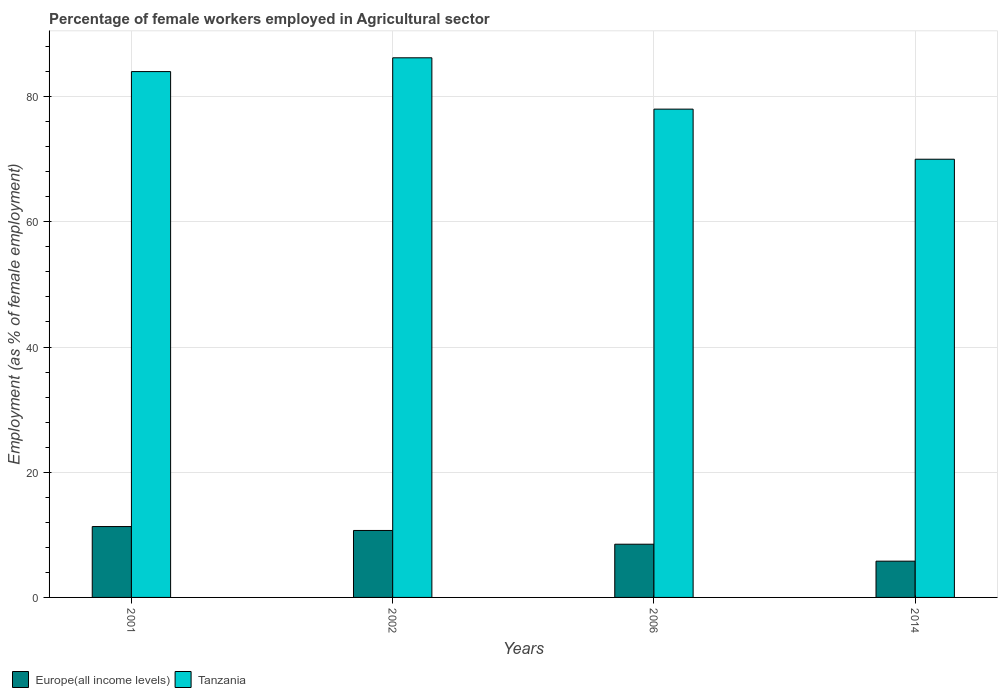Are the number of bars on each tick of the X-axis equal?
Keep it short and to the point. Yes. How many bars are there on the 4th tick from the left?
Give a very brief answer. 2. How many bars are there on the 4th tick from the right?
Offer a very short reply. 2. What is the label of the 2nd group of bars from the left?
Provide a succinct answer. 2002. In how many cases, is the number of bars for a given year not equal to the number of legend labels?
Provide a succinct answer. 0. What is the percentage of females employed in Agricultural sector in Europe(all income levels) in 2006?
Your answer should be very brief. 8.5. Across all years, what is the maximum percentage of females employed in Agricultural sector in Tanzania?
Give a very brief answer. 86.2. Across all years, what is the minimum percentage of females employed in Agricultural sector in Europe(all income levels)?
Provide a succinct answer. 5.79. In which year was the percentage of females employed in Agricultural sector in Tanzania minimum?
Give a very brief answer. 2014. What is the total percentage of females employed in Agricultural sector in Tanzania in the graph?
Provide a succinct answer. 318.2. What is the difference between the percentage of females employed in Agricultural sector in Europe(all income levels) in 2002 and that in 2006?
Keep it short and to the point. 2.2. What is the difference between the percentage of females employed in Agricultural sector in Europe(all income levels) in 2001 and the percentage of females employed in Agricultural sector in Tanzania in 2006?
Your answer should be compact. -66.68. What is the average percentage of females employed in Agricultural sector in Tanzania per year?
Provide a succinct answer. 79.55. In the year 2002, what is the difference between the percentage of females employed in Agricultural sector in Europe(all income levels) and percentage of females employed in Agricultural sector in Tanzania?
Ensure brevity in your answer.  -75.5. In how many years, is the percentage of females employed in Agricultural sector in Europe(all income levels) greater than 4 %?
Keep it short and to the point. 4. What is the ratio of the percentage of females employed in Agricultural sector in Europe(all income levels) in 2002 to that in 2006?
Make the answer very short. 1.26. What is the difference between the highest and the second highest percentage of females employed in Agricultural sector in Tanzania?
Your answer should be compact. 2.2. What is the difference between the highest and the lowest percentage of females employed in Agricultural sector in Tanzania?
Your response must be concise. 16.2. In how many years, is the percentage of females employed in Agricultural sector in Tanzania greater than the average percentage of females employed in Agricultural sector in Tanzania taken over all years?
Your answer should be very brief. 2. Is the sum of the percentage of females employed in Agricultural sector in Tanzania in 2001 and 2002 greater than the maximum percentage of females employed in Agricultural sector in Europe(all income levels) across all years?
Offer a very short reply. Yes. What does the 1st bar from the left in 2006 represents?
Give a very brief answer. Europe(all income levels). What does the 1st bar from the right in 2002 represents?
Your answer should be compact. Tanzania. Are all the bars in the graph horizontal?
Your answer should be compact. No. Does the graph contain any zero values?
Provide a short and direct response. No. Where does the legend appear in the graph?
Give a very brief answer. Bottom left. How many legend labels are there?
Keep it short and to the point. 2. How are the legend labels stacked?
Give a very brief answer. Horizontal. What is the title of the graph?
Your answer should be compact. Percentage of female workers employed in Agricultural sector. What is the label or title of the Y-axis?
Offer a very short reply. Employment (as % of female employment). What is the Employment (as % of female employment) of Europe(all income levels) in 2001?
Offer a terse response. 11.32. What is the Employment (as % of female employment) of Tanzania in 2001?
Offer a terse response. 84. What is the Employment (as % of female employment) in Europe(all income levels) in 2002?
Give a very brief answer. 10.7. What is the Employment (as % of female employment) in Tanzania in 2002?
Ensure brevity in your answer.  86.2. What is the Employment (as % of female employment) of Europe(all income levels) in 2006?
Provide a short and direct response. 8.5. What is the Employment (as % of female employment) of Europe(all income levels) in 2014?
Your response must be concise. 5.79. What is the Employment (as % of female employment) in Tanzania in 2014?
Provide a short and direct response. 70. Across all years, what is the maximum Employment (as % of female employment) in Europe(all income levels)?
Your answer should be compact. 11.32. Across all years, what is the maximum Employment (as % of female employment) in Tanzania?
Provide a short and direct response. 86.2. Across all years, what is the minimum Employment (as % of female employment) of Europe(all income levels)?
Make the answer very short. 5.79. What is the total Employment (as % of female employment) in Europe(all income levels) in the graph?
Keep it short and to the point. 36.31. What is the total Employment (as % of female employment) in Tanzania in the graph?
Give a very brief answer. 318.2. What is the difference between the Employment (as % of female employment) in Europe(all income levels) in 2001 and that in 2002?
Offer a terse response. 0.62. What is the difference between the Employment (as % of female employment) in Europe(all income levels) in 2001 and that in 2006?
Your answer should be very brief. 2.82. What is the difference between the Employment (as % of female employment) in Tanzania in 2001 and that in 2006?
Keep it short and to the point. 6. What is the difference between the Employment (as % of female employment) in Europe(all income levels) in 2001 and that in 2014?
Your answer should be very brief. 5.53. What is the difference between the Employment (as % of female employment) of Europe(all income levels) in 2002 and that in 2006?
Offer a very short reply. 2.2. What is the difference between the Employment (as % of female employment) of Europe(all income levels) in 2002 and that in 2014?
Ensure brevity in your answer.  4.9. What is the difference between the Employment (as % of female employment) of Tanzania in 2002 and that in 2014?
Keep it short and to the point. 16.2. What is the difference between the Employment (as % of female employment) of Europe(all income levels) in 2006 and that in 2014?
Offer a very short reply. 2.71. What is the difference between the Employment (as % of female employment) of Tanzania in 2006 and that in 2014?
Offer a very short reply. 8. What is the difference between the Employment (as % of female employment) of Europe(all income levels) in 2001 and the Employment (as % of female employment) of Tanzania in 2002?
Provide a short and direct response. -74.88. What is the difference between the Employment (as % of female employment) in Europe(all income levels) in 2001 and the Employment (as % of female employment) in Tanzania in 2006?
Offer a very short reply. -66.68. What is the difference between the Employment (as % of female employment) in Europe(all income levels) in 2001 and the Employment (as % of female employment) in Tanzania in 2014?
Your answer should be very brief. -58.68. What is the difference between the Employment (as % of female employment) of Europe(all income levels) in 2002 and the Employment (as % of female employment) of Tanzania in 2006?
Give a very brief answer. -67.3. What is the difference between the Employment (as % of female employment) of Europe(all income levels) in 2002 and the Employment (as % of female employment) of Tanzania in 2014?
Make the answer very short. -59.3. What is the difference between the Employment (as % of female employment) in Europe(all income levels) in 2006 and the Employment (as % of female employment) in Tanzania in 2014?
Ensure brevity in your answer.  -61.5. What is the average Employment (as % of female employment) in Europe(all income levels) per year?
Your answer should be compact. 9.08. What is the average Employment (as % of female employment) in Tanzania per year?
Your answer should be compact. 79.55. In the year 2001, what is the difference between the Employment (as % of female employment) of Europe(all income levels) and Employment (as % of female employment) of Tanzania?
Make the answer very short. -72.68. In the year 2002, what is the difference between the Employment (as % of female employment) of Europe(all income levels) and Employment (as % of female employment) of Tanzania?
Provide a short and direct response. -75.5. In the year 2006, what is the difference between the Employment (as % of female employment) of Europe(all income levels) and Employment (as % of female employment) of Tanzania?
Give a very brief answer. -69.5. In the year 2014, what is the difference between the Employment (as % of female employment) of Europe(all income levels) and Employment (as % of female employment) of Tanzania?
Offer a terse response. -64.21. What is the ratio of the Employment (as % of female employment) of Europe(all income levels) in 2001 to that in 2002?
Your answer should be compact. 1.06. What is the ratio of the Employment (as % of female employment) of Tanzania in 2001 to that in 2002?
Ensure brevity in your answer.  0.97. What is the ratio of the Employment (as % of female employment) in Europe(all income levels) in 2001 to that in 2006?
Make the answer very short. 1.33. What is the ratio of the Employment (as % of female employment) in Tanzania in 2001 to that in 2006?
Offer a very short reply. 1.08. What is the ratio of the Employment (as % of female employment) in Europe(all income levels) in 2001 to that in 2014?
Offer a very short reply. 1.95. What is the ratio of the Employment (as % of female employment) in Europe(all income levels) in 2002 to that in 2006?
Provide a succinct answer. 1.26. What is the ratio of the Employment (as % of female employment) of Tanzania in 2002 to that in 2006?
Keep it short and to the point. 1.11. What is the ratio of the Employment (as % of female employment) in Europe(all income levels) in 2002 to that in 2014?
Offer a very short reply. 1.85. What is the ratio of the Employment (as % of female employment) of Tanzania in 2002 to that in 2014?
Your answer should be very brief. 1.23. What is the ratio of the Employment (as % of female employment) of Europe(all income levels) in 2006 to that in 2014?
Your response must be concise. 1.47. What is the ratio of the Employment (as % of female employment) in Tanzania in 2006 to that in 2014?
Ensure brevity in your answer.  1.11. What is the difference between the highest and the second highest Employment (as % of female employment) in Europe(all income levels)?
Offer a terse response. 0.62. What is the difference between the highest and the second highest Employment (as % of female employment) of Tanzania?
Your answer should be very brief. 2.2. What is the difference between the highest and the lowest Employment (as % of female employment) in Europe(all income levels)?
Your response must be concise. 5.53. What is the difference between the highest and the lowest Employment (as % of female employment) of Tanzania?
Keep it short and to the point. 16.2. 